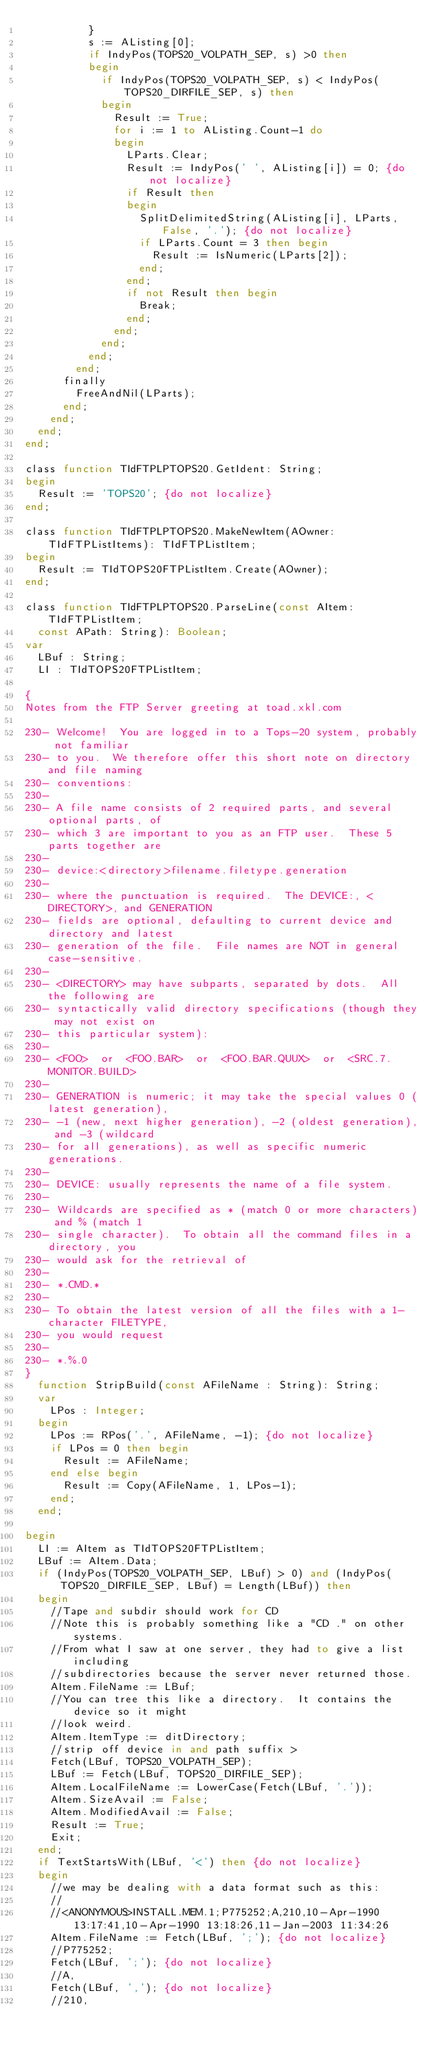Convert code to text. <code><loc_0><loc_0><loc_500><loc_500><_Pascal_>          }
          s := AListing[0];
          if IndyPos(TOPS20_VOLPATH_SEP, s) >0 then
          begin
            if IndyPos(TOPS20_VOLPATH_SEP, s) < IndyPos(TOPS20_DIRFILE_SEP, s) then
            begin
              Result := True;
              for i := 1 to AListing.Count-1 do
              begin
                LParts.Clear;
                Result := IndyPos(' ', AListing[i]) = 0; {do not localize}
                if Result then
                begin
                  SplitDelimitedString(AListing[i], LParts, False, '.'); {do not localize}
                  if LParts.Count = 3 then begin
                    Result := IsNumeric(LParts[2]);
                  end;
                end;
                if not Result then begin
                  Break;
                end;
              end;
            end;
          end;
        end;
      finally
        FreeAndNil(LParts);
      end;
    end;
  end;
end;

class function TIdFTPLPTOPS20.GetIdent: String;
begin
  Result := 'TOPS20'; {do not localize}
end;

class function TIdFTPLPTOPS20.MakeNewItem(AOwner: TIdFTPListItems): TIdFTPListItem;
begin
  Result := TIdTOPS20FTPListItem.Create(AOwner);
end;

class function TIdFTPLPTOPS20.ParseLine(const AItem: TIdFTPListItem;
  const APath: String): Boolean;
var
  LBuf : String;
  LI : TIdTOPS20FTPListItem;

{
Notes from the FTP Server greeting at toad.xkl.com

230- Welcome!  You are logged in to a Tops-20 system, probably not familiar
230- to you.  We therefore offer this short note on directory and file naming
230- conventions:
230-
230- A file name consists of 2 required parts, and several optional parts, of
230- which 3 are important to you as an FTP user.  These 5 parts together are
230-
230- device:<directory>filename.filetype.generation
230-
230- where the punctuation is required.  The DEVICE:, <DIRECTORY>, and GENERATION
230- fields are optional, defaulting to current device and directory and latest
230- generation of the file.  File names are NOT in general case-sensitive.
230-
230- <DIRECTORY> may have subparts, separated by dots.  All the following are
230- syntactically valid directory specifications (though they may not exist on
230- this particular system):
230-
230- <FOO>  or  <FOO.BAR>  or  <FOO.BAR.QUUX>  or  <SRC.7.MONITOR.BUILD>
230-
230- GENERATION is numeric; it may take the special values 0 (latest generation),
230- -1 (new, next higher generation), -2 (oldest generation), and -3 (wildcard
230- for all generations), as well as specific numeric generations.
230-
230- DEVICE: usually represents the name of a file system.
230-
230- Wildcards are specified as * (match 0 or more characters) and % (match 1
230- single character).  To obtain all the command files in a directory, you
230- would ask for the retrieval of
230-
230- *.CMD.*
230-
230- To obtain the latest version of all the files with a 1-character FILETYPE,
230- you would request
230-
230- *.%.0
}
  function StripBuild(const AFileName : String): String;
  var
    LPos : Integer;
  begin
    LPos := RPos('.', AFileName, -1); {do not localize}
    if LPos = 0 then begin
      Result := AFileName;
    end else begin
      Result := Copy(AFileName, 1, LPos-1);
    end;
  end;

begin
  LI := AItem as TIdTOPS20FTPListItem;
  LBuf := AItem.Data;
  if (IndyPos(TOPS20_VOLPATH_SEP, LBuf) > 0) and (IndyPos(TOPS20_DIRFILE_SEP, LBuf) = Length(LBuf)) then
  begin
    //Tape and subdir should work for CD
    //Note this is probably something like a "CD ." on other systems.
    //From what I saw at one server, they had to give a list including
    //subdirectories because the server never returned those.
    AItem.FileName := LBuf;
    //You can tree this like a directory.  It contains the device so it might
    //look weird.
    AItem.ItemType := ditDirectory;
    //strip off device in and path suffix >
    Fetch(LBuf, TOPS20_VOLPATH_SEP);
    LBuf := Fetch(LBuf, TOPS20_DIRFILE_SEP);
    AItem.LocalFileName := LowerCase(Fetch(LBuf, '.'));
    AItem.SizeAvail := False;
    AItem.ModifiedAvail := False;
    Result := True;
    Exit;
  end;
  if TextStartsWith(LBuf, '<') then {do not localize}
  begin
    //we may be dealing with a data format such as this:
    //
    //<ANONYMOUS>INSTALL.MEM.1;P775252;A,210,10-Apr-1990 13:17:41,10-Apr-1990 13:18:26,11-Jan-2003 11:34:26
    AItem.FileName := Fetch(LBuf, ';'); {do not localize}
    //P775252;
    Fetch(LBuf, ';'); {do not localize}
    //A,
    Fetch(LBuf, ','); {do not localize}
    //210,</code> 